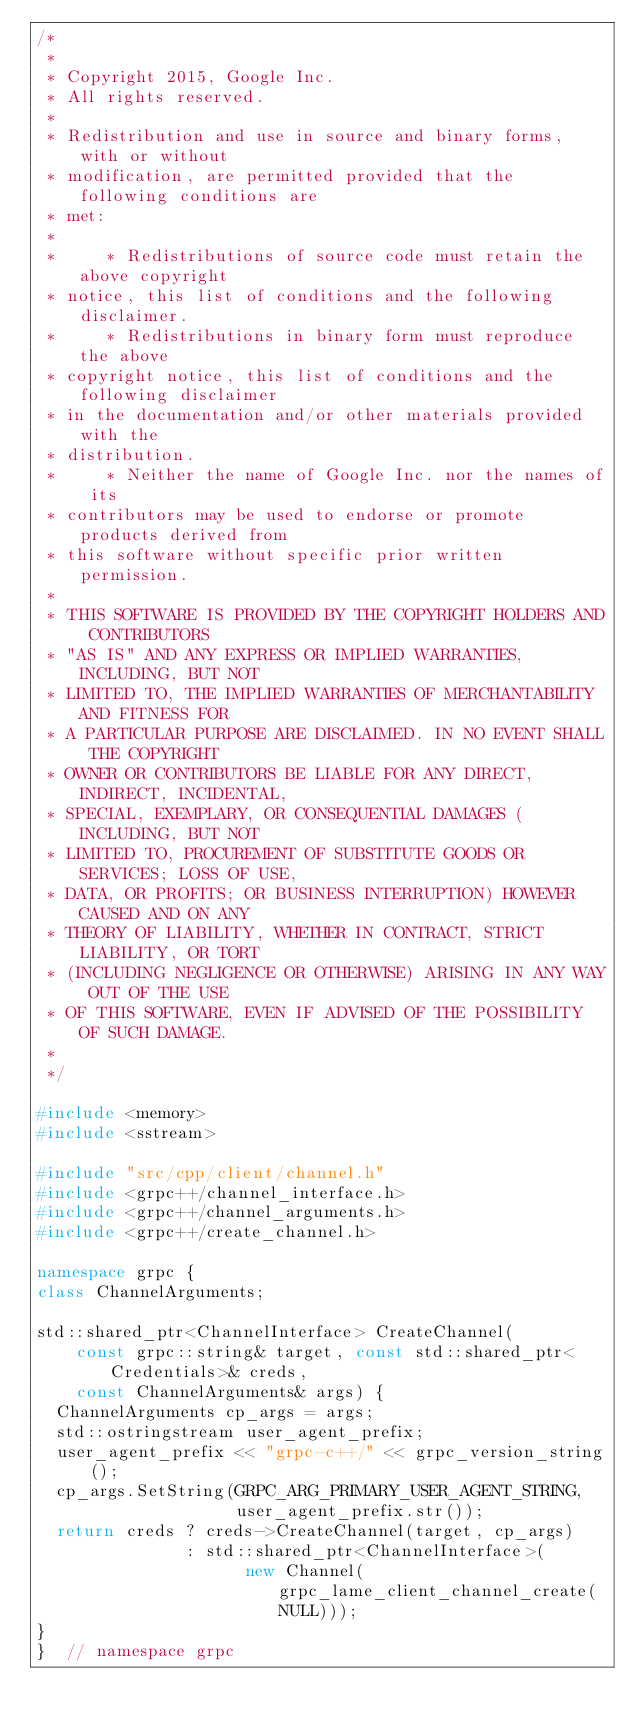<code> <loc_0><loc_0><loc_500><loc_500><_C++_>/*
 *
 * Copyright 2015, Google Inc.
 * All rights reserved.
 *
 * Redistribution and use in source and binary forms, with or without
 * modification, are permitted provided that the following conditions are
 * met:
 *
 *     * Redistributions of source code must retain the above copyright
 * notice, this list of conditions and the following disclaimer.
 *     * Redistributions in binary form must reproduce the above
 * copyright notice, this list of conditions and the following disclaimer
 * in the documentation and/or other materials provided with the
 * distribution.
 *     * Neither the name of Google Inc. nor the names of its
 * contributors may be used to endorse or promote products derived from
 * this software without specific prior written permission.
 *
 * THIS SOFTWARE IS PROVIDED BY THE COPYRIGHT HOLDERS AND CONTRIBUTORS
 * "AS IS" AND ANY EXPRESS OR IMPLIED WARRANTIES, INCLUDING, BUT NOT
 * LIMITED TO, THE IMPLIED WARRANTIES OF MERCHANTABILITY AND FITNESS FOR
 * A PARTICULAR PURPOSE ARE DISCLAIMED. IN NO EVENT SHALL THE COPYRIGHT
 * OWNER OR CONTRIBUTORS BE LIABLE FOR ANY DIRECT, INDIRECT, INCIDENTAL,
 * SPECIAL, EXEMPLARY, OR CONSEQUENTIAL DAMAGES (INCLUDING, BUT NOT
 * LIMITED TO, PROCUREMENT OF SUBSTITUTE GOODS OR SERVICES; LOSS OF USE,
 * DATA, OR PROFITS; OR BUSINESS INTERRUPTION) HOWEVER CAUSED AND ON ANY
 * THEORY OF LIABILITY, WHETHER IN CONTRACT, STRICT LIABILITY, OR TORT
 * (INCLUDING NEGLIGENCE OR OTHERWISE) ARISING IN ANY WAY OUT OF THE USE
 * OF THIS SOFTWARE, EVEN IF ADVISED OF THE POSSIBILITY OF SUCH DAMAGE.
 *
 */

#include <memory>
#include <sstream>

#include "src/cpp/client/channel.h"
#include <grpc++/channel_interface.h>
#include <grpc++/channel_arguments.h>
#include <grpc++/create_channel.h>

namespace grpc {
class ChannelArguments;

std::shared_ptr<ChannelInterface> CreateChannel(
    const grpc::string& target, const std::shared_ptr<Credentials>& creds,
    const ChannelArguments& args) {
  ChannelArguments cp_args = args;
  std::ostringstream user_agent_prefix;
  user_agent_prefix << "grpc-c++/" << grpc_version_string();
  cp_args.SetString(GRPC_ARG_PRIMARY_USER_AGENT_STRING,
                    user_agent_prefix.str());
  return creds ? creds->CreateChannel(target, cp_args)
               : std::shared_ptr<ChannelInterface>(
                     new Channel(grpc_lame_client_channel_create(NULL)));
}
}  // namespace grpc
</code> 